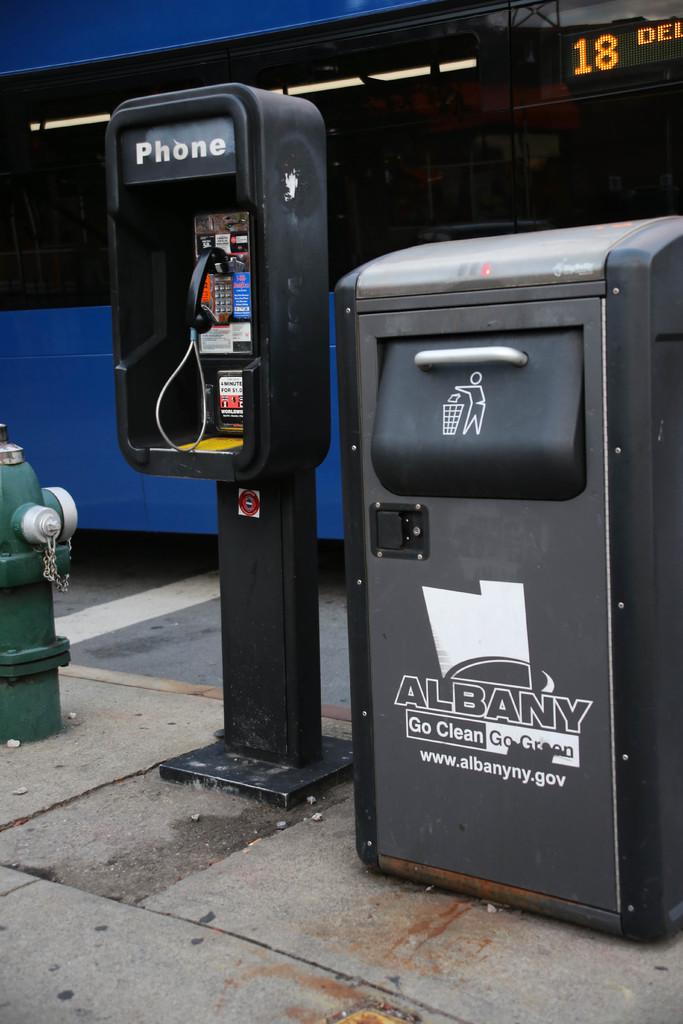What city does this image take place in?
Give a very brief answer. Albany. What is the web address for this company?
Offer a terse response. Www.albanyny.gov. 